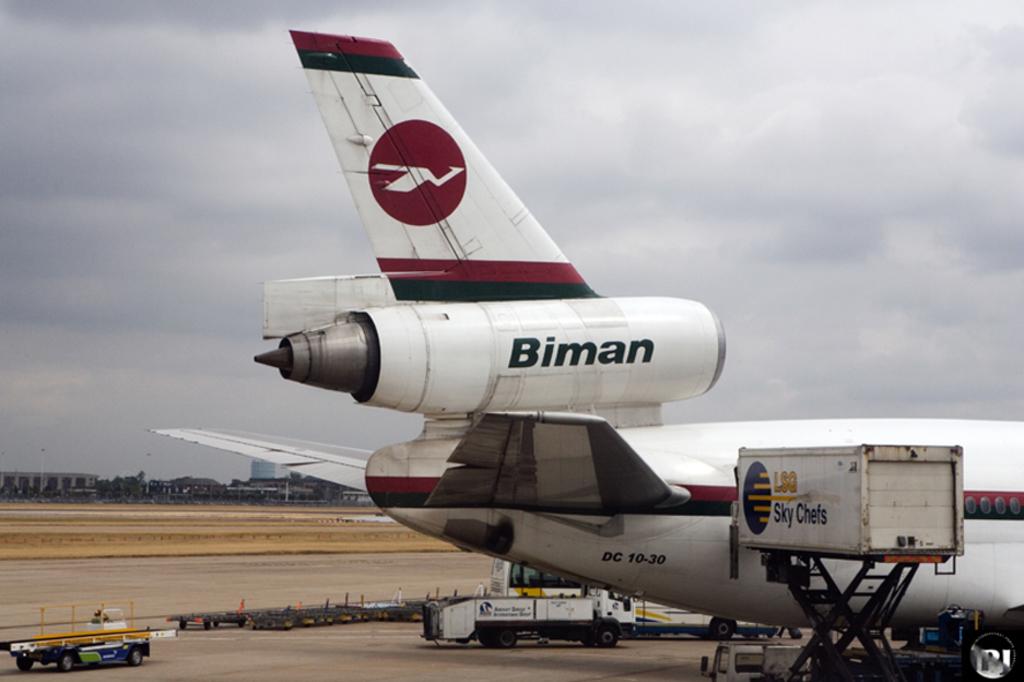What made this airplane?
Ensure brevity in your answer.  Biman. What kind of plane is this?
Provide a succinct answer. Biman. 